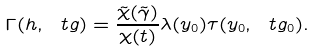Convert formula to latex. <formula><loc_0><loc_0><loc_500><loc_500>\Gamma ( h , \ t g ) = \frac { \tilde { \chi } ( \tilde { \gamma } ) } { \chi ( t ) } \lambda ( y _ { 0 } ) \tau ( y _ { 0 } , \ t g _ { 0 } ) .</formula> 